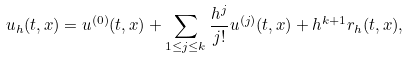Convert formula to latex. <formula><loc_0><loc_0><loc_500><loc_500>u _ { h } ( t , x ) = u ^ { ( 0 ) } ( t , x ) + \sum _ { 1 \leq j \leq k } \frac { h ^ { j } } { j ! } u ^ { ( j ) } ( t , x ) + h ^ { k + 1 } r _ { h } ( t , x ) ,</formula> 